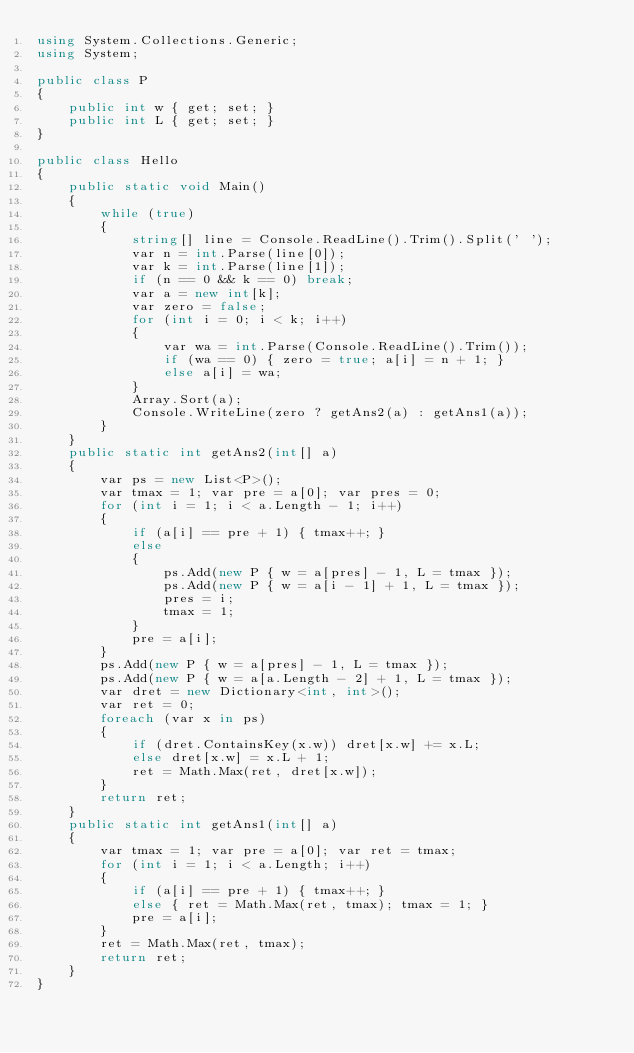Convert code to text. <code><loc_0><loc_0><loc_500><loc_500><_C#_>using System.Collections.Generic;
using System;

public class P
{
    public int w { get; set; }
    public int L { get; set; }
}

public class Hello
{
    public static void Main()
    {
        while (true)
        {
            string[] line = Console.ReadLine().Trim().Split(' ');
            var n = int.Parse(line[0]);
            var k = int.Parse(line[1]);
            if (n == 0 && k == 0) break;
            var a = new int[k];
            var zero = false;
            for (int i = 0; i < k; i++)
            {
                var wa = int.Parse(Console.ReadLine().Trim());
                if (wa == 0) { zero = true; a[i] = n + 1; }
                else a[i] = wa;
            }
            Array.Sort(a);
            Console.WriteLine(zero ? getAns2(a) : getAns1(a));
        }
    }
    public static int getAns2(int[] a)
    {
        var ps = new List<P>();
        var tmax = 1; var pre = a[0]; var pres = 0;
        for (int i = 1; i < a.Length - 1; i++)
        {
            if (a[i] == pre + 1) { tmax++; }
            else
            {
                ps.Add(new P { w = a[pres] - 1, L = tmax });
                ps.Add(new P { w = a[i - 1] + 1, L = tmax });
                pres = i;
                tmax = 1;
            }
            pre = a[i];
        }
        ps.Add(new P { w = a[pres] - 1, L = tmax });
        ps.Add(new P { w = a[a.Length - 2] + 1, L = tmax });
        var dret = new Dictionary<int, int>();
        var ret = 0;
        foreach (var x in ps)
        {
            if (dret.ContainsKey(x.w)) dret[x.w] += x.L;
            else dret[x.w] = x.L + 1;
            ret = Math.Max(ret, dret[x.w]);
        }
        return ret;
    }
    public static int getAns1(int[] a)
    {
        var tmax = 1; var pre = a[0]; var ret = tmax;
        for (int i = 1; i < a.Length; i++)
        {
            if (a[i] == pre + 1) { tmax++; }
            else { ret = Math.Max(ret, tmax); tmax = 1; }
            pre = a[i];
        }
        ret = Math.Max(ret, tmax);
        return ret;
    }
}
</code> 